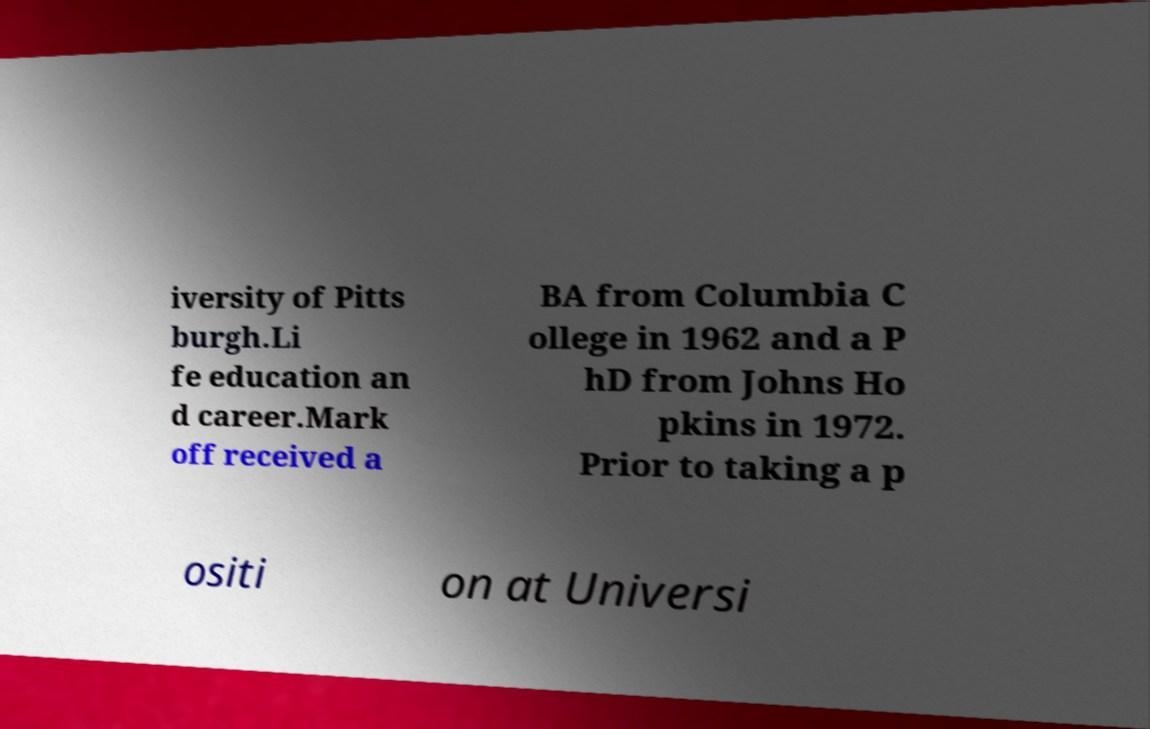Could you extract and type out the text from this image? iversity of Pitts burgh.Li fe education an d career.Mark off received a BA from Columbia C ollege in 1962 and a P hD from Johns Ho pkins in 1972. Prior to taking a p ositi on at Universi 